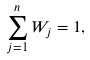<formula> <loc_0><loc_0><loc_500><loc_500>\sum _ { j = 1 } ^ { n } W _ { j } = 1 ,</formula> 